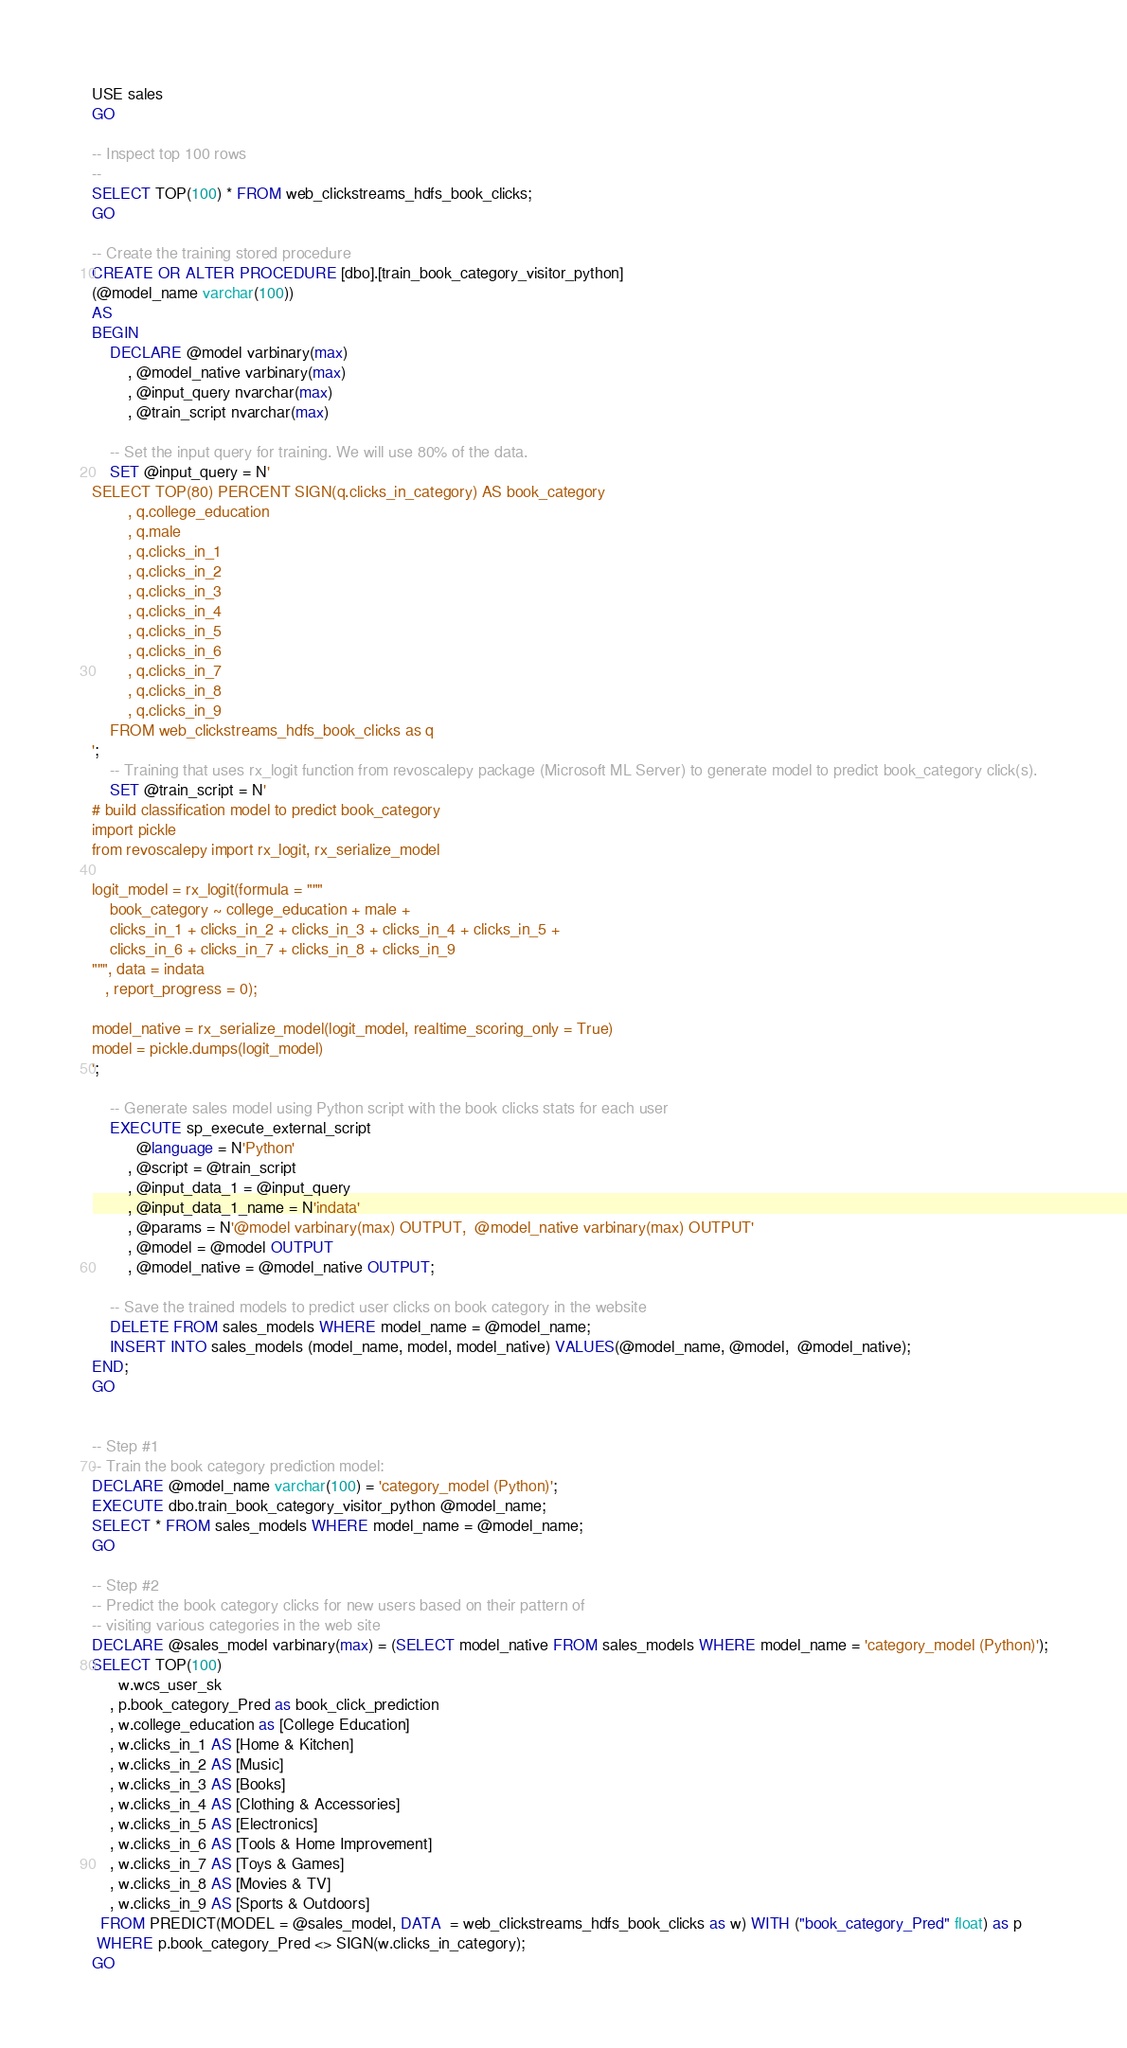<code> <loc_0><loc_0><loc_500><loc_500><_SQL_>USE sales
GO

-- Inspect top 100 rows
--
SELECT TOP(100) * FROM web_clickstreams_hdfs_book_clicks;
GO

-- Create the training stored procedure
CREATE OR ALTER PROCEDURE [dbo].[train_book_category_visitor_python]
(@model_name varchar(100))
AS
BEGIN
	DECLARE @model varbinary(max)
		, @model_native varbinary(max)
		, @input_query nvarchar(max)
		, @train_script nvarchar(max)
		
	-- Set the input query for training. We will use 80% of the data.
	SET @input_query = N'
SELECT TOP(80) PERCENT SIGN(q.clicks_in_category) AS book_category
		, q.college_education
		, q.male
		, q.clicks_in_1
		, q.clicks_in_2
		, q.clicks_in_3
		, q.clicks_in_4
		, q.clicks_in_5
		, q.clicks_in_6
		, q.clicks_in_7
		, q.clicks_in_8
		, q.clicks_in_9
	FROM web_clickstreams_hdfs_book_clicks as q
';
	-- Training that uses rx_logit function from revoscalepy package (Microsoft ML Server) to generate model to predict book_category click(s).
	SET @train_script = N'
# build classification model to predict book_category
import pickle
from revoscalepy import rx_logit, rx_serialize_model

logit_model = rx_logit(formula = """
	book_category ~ college_education + male +
	clicks_in_1 + clicks_in_2 + clicks_in_3 + clicks_in_4 + clicks_in_5 +
	clicks_in_6 + clicks_in_7 + clicks_in_8 + clicks_in_9
""", data = indata
   , report_progress = 0);

model_native = rx_serialize_model(logit_model, realtime_scoring_only = True)
model = pickle.dumps(logit_model)
';

	-- Generate sales model using Python script with the book clicks stats for each user
	EXECUTE sp_execute_external_script
		  @language = N'Python'
		, @script = @train_script
		, @input_data_1 = @input_query
		, @input_data_1_name = N'indata'
		, @params = N'@model varbinary(max) OUTPUT,  @model_native varbinary(max) OUTPUT'
		, @model = @model OUTPUT
		, @model_native = @model_native OUTPUT;

	-- Save the trained models to predict user clicks on book category in the website
	DELETE FROM sales_models WHERE model_name = @model_name;
	INSERT INTO sales_models (model_name, model, model_native) VALUES(@model_name, @model,  @model_native);
END;
GO


-- Step #1
-- Train the book category prediction model:
DECLARE @model_name varchar(100) = 'category_model (Python)';
EXECUTE dbo.train_book_category_visitor_python @model_name;
SELECT * FROM sales_models WHERE model_name = @model_name;
GO

-- Step #2
-- Predict the book category clicks for new users based on their pattern of 
-- visiting various categories in the web site
DECLARE @sales_model varbinary(max) = (SELECT model_native FROM sales_models WHERE model_name = 'category_model (Python)');
SELECT TOP(100)
      w.wcs_user_sk
	, p.book_category_Pred as book_click_prediction
	, w.college_education as [College Education]
	, w.clicks_in_1 AS [Home & Kitchen]
	, w.clicks_in_2 AS [Music]
	, w.clicks_in_3 AS [Books]
	, w.clicks_in_4 AS [Clothing & Accessories]
	, w.clicks_in_5 AS [Electronics]
	, w.clicks_in_6 AS [Tools & Home Improvement]
	, w.clicks_in_7 AS [Toys & Games]
	, w.clicks_in_8 AS [Movies & TV]
	, w.clicks_in_9 AS [Sports & Outdoors]
  FROM PREDICT(MODEL = @sales_model, DATA  = web_clickstreams_hdfs_book_clicks as w) WITH ("book_category_Pred" float) as p
 WHERE p.book_category_Pred <> SIGN(w.clicks_in_category);
GO
</code> 